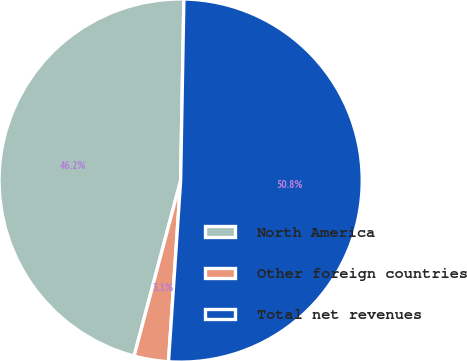<chart> <loc_0><loc_0><loc_500><loc_500><pie_chart><fcel>North America<fcel>Other foreign countries<fcel>Total net revenues<nl><fcel>46.16%<fcel>3.06%<fcel>50.78%<nl></chart> 